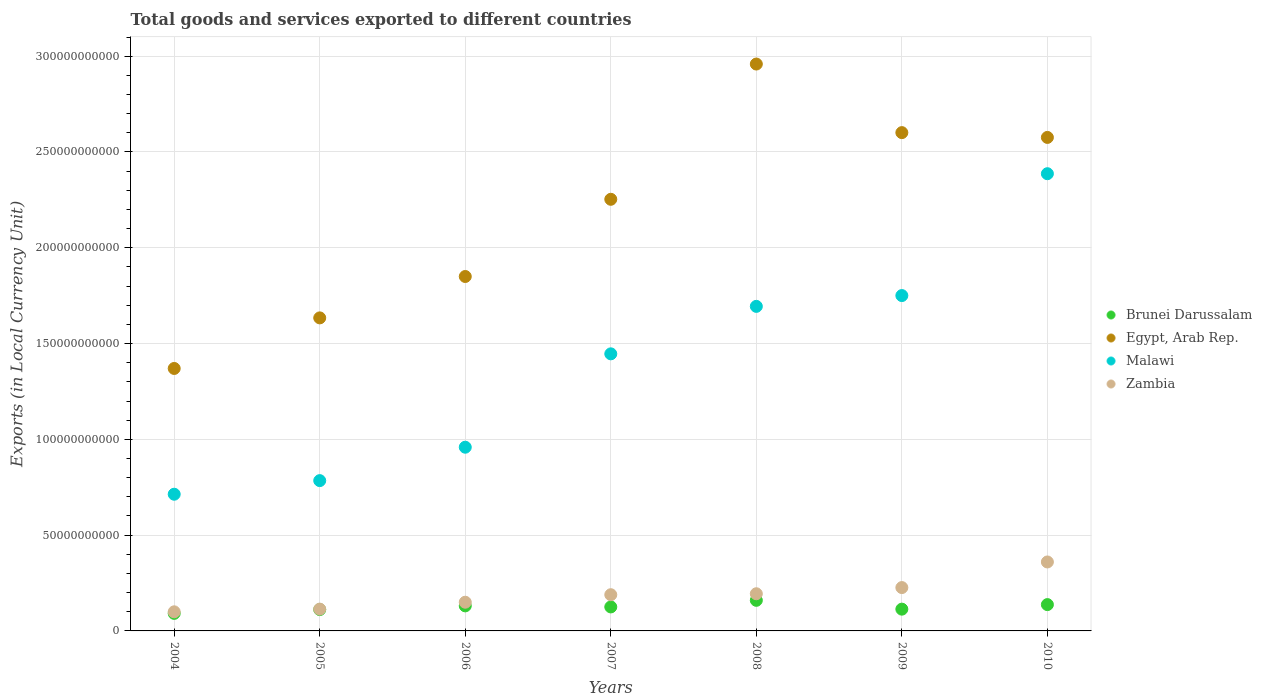Is the number of dotlines equal to the number of legend labels?
Your answer should be compact. Yes. What is the Amount of goods and services exports in Brunei Darussalam in 2007?
Make the answer very short. 1.25e+1. Across all years, what is the maximum Amount of goods and services exports in Brunei Darussalam?
Your answer should be very brief. 1.60e+1. Across all years, what is the minimum Amount of goods and services exports in Egypt, Arab Rep.?
Make the answer very short. 1.37e+11. In which year was the Amount of goods and services exports in Brunei Darussalam minimum?
Ensure brevity in your answer.  2004. What is the total Amount of goods and services exports in Brunei Darussalam in the graph?
Offer a very short reply. 8.70e+1. What is the difference between the Amount of goods and services exports in Egypt, Arab Rep. in 2005 and that in 2006?
Offer a very short reply. -2.16e+1. What is the difference between the Amount of goods and services exports in Zambia in 2006 and the Amount of goods and services exports in Brunei Darussalam in 2010?
Keep it short and to the point. 1.24e+09. What is the average Amount of goods and services exports in Malawi per year?
Your answer should be compact. 1.39e+11. In the year 2005, what is the difference between the Amount of goods and services exports in Zambia and Amount of goods and services exports in Brunei Darussalam?
Give a very brief answer. 2.52e+08. In how many years, is the Amount of goods and services exports in Egypt, Arab Rep. greater than 190000000000 LCU?
Your answer should be very brief. 4. What is the ratio of the Amount of goods and services exports in Zambia in 2006 to that in 2008?
Provide a succinct answer. 0.77. What is the difference between the highest and the second highest Amount of goods and services exports in Zambia?
Offer a terse response. 1.34e+1. What is the difference between the highest and the lowest Amount of goods and services exports in Malawi?
Your answer should be very brief. 1.67e+11. Is the Amount of goods and services exports in Malawi strictly greater than the Amount of goods and services exports in Brunei Darussalam over the years?
Offer a terse response. Yes. Is the Amount of goods and services exports in Zambia strictly less than the Amount of goods and services exports in Egypt, Arab Rep. over the years?
Give a very brief answer. Yes. How many dotlines are there?
Give a very brief answer. 4. How many years are there in the graph?
Offer a very short reply. 7. What is the difference between two consecutive major ticks on the Y-axis?
Give a very brief answer. 5.00e+1. Does the graph contain any zero values?
Make the answer very short. No. Does the graph contain grids?
Make the answer very short. Yes. How many legend labels are there?
Keep it short and to the point. 4. What is the title of the graph?
Provide a succinct answer. Total goods and services exported to different countries. What is the label or title of the X-axis?
Provide a succinct answer. Years. What is the label or title of the Y-axis?
Keep it short and to the point. Exports (in Local Currency Unit). What is the Exports (in Local Currency Unit) of Brunei Darussalam in 2004?
Give a very brief answer. 9.15e+09. What is the Exports (in Local Currency Unit) in Egypt, Arab Rep. in 2004?
Make the answer very short. 1.37e+11. What is the Exports (in Local Currency Unit) in Malawi in 2004?
Your answer should be very brief. 7.14e+1. What is the Exports (in Local Currency Unit) in Zambia in 2004?
Offer a terse response. 9.97e+09. What is the Exports (in Local Currency Unit) of Brunei Darussalam in 2005?
Offer a terse response. 1.11e+1. What is the Exports (in Local Currency Unit) of Egypt, Arab Rep. in 2005?
Provide a short and direct response. 1.63e+11. What is the Exports (in Local Currency Unit) in Malawi in 2005?
Ensure brevity in your answer.  7.85e+1. What is the Exports (in Local Currency Unit) of Zambia in 2005?
Keep it short and to the point. 1.14e+1. What is the Exports (in Local Currency Unit) of Brunei Darussalam in 2006?
Keep it short and to the point. 1.31e+1. What is the Exports (in Local Currency Unit) of Egypt, Arab Rep. in 2006?
Offer a terse response. 1.85e+11. What is the Exports (in Local Currency Unit) in Malawi in 2006?
Give a very brief answer. 9.59e+1. What is the Exports (in Local Currency Unit) in Zambia in 2006?
Offer a terse response. 1.50e+1. What is the Exports (in Local Currency Unit) in Brunei Darussalam in 2007?
Give a very brief answer. 1.25e+1. What is the Exports (in Local Currency Unit) of Egypt, Arab Rep. in 2007?
Give a very brief answer. 2.25e+11. What is the Exports (in Local Currency Unit) in Malawi in 2007?
Provide a short and direct response. 1.45e+11. What is the Exports (in Local Currency Unit) in Zambia in 2007?
Provide a short and direct response. 1.89e+1. What is the Exports (in Local Currency Unit) of Brunei Darussalam in 2008?
Make the answer very short. 1.60e+1. What is the Exports (in Local Currency Unit) in Egypt, Arab Rep. in 2008?
Make the answer very short. 2.96e+11. What is the Exports (in Local Currency Unit) of Malawi in 2008?
Ensure brevity in your answer.  1.69e+11. What is the Exports (in Local Currency Unit) in Zambia in 2008?
Make the answer very short. 1.94e+1. What is the Exports (in Local Currency Unit) in Brunei Darussalam in 2009?
Give a very brief answer. 1.14e+1. What is the Exports (in Local Currency Unit) of Egypt, Arab Rep. in 2009?
Make the answer very short. 2.60e+11. What is the Exports (in Local Currency Unit) of Malawi in 2009?
Your answer should be compact. 1.75e+11. What is the Exports (in Local Currency Unit) of Zambia in 2009?
Your response must be concise. 2.26e+1. What is the Exports (in Local Currency Unit) in Brunei Darussalam in 2010?
Keep it short and to the point. 1.37e+1. What is the Exports (in Local Currency Unit) of Egypt, Arab Rep. in 2010?
Offer a terse response. 2.58e+11. What is the Exports (in Local Currency Unit) of Malawi in 2010?
Your response must be concise. 2.39e+11. What is the Exports (in Local Currency Unit) of Zambia in 2010?
Keep it short and to the point. 3.60e+1. Across all years, what is the maximum Exports (in Local Currency Unit) in Brunei Darussalam?
Provide a short and direct response. 1.60e+1. Across all years, what is the maximum Exports (in Local Currency Unit) in Egypt, Arab Rep.?
Your answer should be very brief. 2.96e+11. Across all years, what is the maximum Exports (in Local Currency Unit) in Malawi?
Your answer should be compact. 2.39e+11. Across all years, what is the maximum Exports (in Local Currency Unit) of Zambia?
Provide a short and direct response. 3.60e+1. Across all years, what is the minimum Exports (in Local Currency Unit) of Brunei Darussalam?
Your response must be concise. 9.15e+09. Across all years, what is the minimum Exports (in Local Currency Unit) of Egypt, Arab Rep.?
Provide a short and direct response. 1.37e+11. Across all years, what is the minimum Exports (in Local Currency Unit) of Malawi?
Your answer should be very brief. 7.14e+1. Across all years, what is the minimum Exports (in Local Currency Unit) in Zambia?
Provide a short and direct response. 9.97e+09. What is the total Exports (in Local Currency Unit) of Brunei Darussalam in the graph?
Provide a succinct answer. 8.70e+1. What is the total Exports (in Local Currency Unit) in Egypt, Arab Rep. in the graph?
Keep it short and to the point. 1.52e+12. What is the total Exports (in Local Currency Unit) of Malawi in the graph?
Your response must be concise. 9.73e+11. What is the total Exports (in Local Currency Unit) in Zambia in the graph?
Provide a succinct answer. 1.33e+11. What is the difference between the Exports (in Local Currency Unit) in Brunei Darussalam in 2004 and that in 2005?
Offer a very short reply. -1.98e+09. What is the difference between the Exports (in Local Currency Unit) of Egypt, Arab Rep. in 2004 and that in 2005?
Provide a succinct answer. -2.64e+1. What is the difference between the Exports (in Local Currency Unit) in Malawi in 2004 and that in 2005?
Make the answer very short. -7.10e+09. What is the difference between the Exports (in Local Currency Unit) of Zambia in 2004 and that in 2005?
Your response must be concise. -1.41e+09. What is the difference between the Exports (in Local Currency Unit) of Brunei Darussalam in 2004 and that in 2006?
Make the answer very short. -3.92e+09. What is the difference between the Exports (in Local Currency Unit) of Egypt, Arab Rep. in 2004 and that in 2006?
Give a very brief answer. -4.80e+1. What is the difference between the Exports (in Local Currency Unit) in Malawi in 2004 and that in 2006?
Make the answer very short. -2.45e+1. What is the difference between the Exports (in Local Currency Unit) in Zambia in 2004 and that in 2006?
Provide a short and direct response. -5.01e+09. What is the difference between the Exports (in Local Currency Unit) in Brunei Darussalam in 2004 and that in 2007?
Your answer should be very brief. -3.37e+09. What is the difference between the Exports (in Local Currency Unit) in Egypt, Arab Rep. in 2004 and that in 2007?
Make the answer very short. -8.83e+1. What is the difference between the Exports (in Local Currency Unit) of Malawi in 2004 and that in 2007?
Provide a succinct answer. -7.33e+1. What is the difference between the Exports (in Local Currency Unit) in Zambia in 2004 and that in 2007?
Offer a very short reply. -8.93e+09. What is the difference between the Exports (in Local Currency Unit) in Brunei Darussalam in 2004 and that in 2008?
Your response must be concise. -6.82e+09. What is the difference between the Exports (in Local Currency Unit) in Egypt, Arab Rep. in 2004 and that in 2008?
Offer a very short reply. -1.59e+11. What is the difference between the Exports (in Local Currency Unit) of Malawi in 2004 and that in 2008?
Your answer should be very brief. -9.81e+1. What is the difference between the Exports (in Local Currency Unit) in Zambia in 2004 and that in 2008?
Offer a terse response. -9.43e+09. What is the difference between the Exports (in Local Currency Unit) in Brunei Darussalam in 2004 and that in 2009?
Provide a succinct answer. -2.21e+09. What is the difference between the Exports (in Local Currency Unit) in Egypt, Arab Rep. in 2004 and that in 2009?
Ensure brevity in your answer.  -1.23e+11. What is the difference between the Exports (in Local Currency Unit) of Malawi in 2004 and that in 2009?
Keep it short and to the point. -1.04e+11. What is the difference between the Exports (in Local Currency Unit) in Zambia in 2004 and that in 2009?
Offer a very short reply. -1.27e+1. What is the difference between the Exports (in Local Currency Unit) in Brunei Darussalam in 2004 and that in 2010?
Provide a succinct answer. -4.58e+09. What is the difference between the Exports (in Local Currency Unit) in Egypt, Arab Rep. in 2004 and that in 2010?
Your answer should be compact. -1.21e+11. What is the difference between the Exports (in Local Currency Unit) of Malawi in 2004 and that in 2010?
Keep it short and to the point. -1.67e+11. What is the difference between the Exports (in Local Currency Unit) in Zambia in 2004 and that in 2010?
Provide a succinct answer. -2.60e+1. What is the difference between the Exports (in Local Currency Unit) in Brunei Darussalam in 2005 and that in 2006?
Give a very brief answer. -1.94e+09. What is the difference between the Exports (in Local Currency Unit) in Egypt, Arab Rep. in 2005 and that in 2006?
Your response must be concise. -2.16e+1. What is the difference between the Exports (in Local Currency Unit) of Malawi in 2005 and that in 2006?
Your answer should be compact. -1.74e+1. What is the difference between the Exports (in Local Currency Unit) of Zambia in 2005 and that in 2006?
Give a very brief answer. -3.60e+09. What is the difference between the Exports (in Local Currency Unit) in Brunei Darussalam in 2005 and that in 2007?
Your response must be concise. -1.39e+09. What is the difference between the Exports (in Local Currency Unit) of Egypt, Arab Rep. in 2005 and that in 2007?
Provide a succinct answer. -6.19e+1. What is the difference between the Exports (in Local Currency Unit) in Malawi in 2005 and that in 2007?
Offer a very short reply. -6.62e+1. What is the difference between the Exports (in Local Currency Unit) in Zambia in 2005 and that in 2007?
Give a very brief answer. -7.52e+09. What is the difference between the Exports (in Local Currency Unit) of Brunei Darussalam in 2005 and that in 2008?
Give a very brief answer. -4.84e+09. What is the difference between the Exports (in Local Currency Unit) in Egypt, Arab Rep. in 2005 and that in 2008?
Provide a short and direct response. -1.32e+11. What is the difference between the Exports (in Local Currency Unit) in Malawi in 2005 and that in 2008?
Give a very brief answer. -9.10e+1. What is the difference between the Exports (in Local Currency Unit) in Zambia in 2005 and that in 2008?
Your answer should be very brief. -8.02e+09. What is the difference between the Exports (in Local Currency Unit) in Brunei Darussalam in 2005 and that in 2009?
Provide a short and direct response. -2.31e+08. What is the difference between the Exports (in Local Currency Unit) of Egypt, Arab Rep. in 2005 and that in 2009?
Ensure brevity in your answer.  -9.67e+1. What is the difference between the Exports (in Local Currency Unit) in Malawi in 2005 and that in 2009?
Provide a short and direct response. -9.66e+1. What is the difference between the Exports (in Local Currency Unit) of Zambia in 2005 and that in 2009?
Provide a short and direct response. -1.12e+1. What is the difference between the Exports (in Local Currency Unit) of Brunei Darussalam in 2005 and that in 2010?
Your answer should be very brief. -2.60e+09. What is the difference between the Exports (in Local Currency Unit) in Egypt, Arab Rep. in 2005 and that in 2010?
Give a very brief answer. -9.42e+1. What is the difference between the Exports (in Local Currency Unit) in Malawi in 2005 and that in 2010?
Your answer should be compact. -1.60e+11. What is the difference between the Exports (in Local Currency Unit) in Zambia in 2005 and that in 2010?
Give a very brief answer. -2.46e+1. What is the difference between the Exports (in Local Currency Unit) of Brunei Darussalam in 2006 and that in 2007?
Offer a terse response. 5.48e+08. What is the difference between the Exports (in Local Currency Unit) of Egypt, Arab Rep. in 2006 and that in 2007?
Ensure brevity in your answer.  -4.03e+1. What is the difference between the Exports (in Local Currency Unit) in Malawi in 2006 and that in 2007?
Keep it short and to the point. -4.87e+1. What is the difference between the Exports (in Local Currency Unit) of Zambia in 2006 and that in 2007?
Provide a short and direct response. -3.92e+09. What is the difference between the Exports (in Local Currency Unit) in Brunei Darussalam in 2006 and that in 2008?
Offer a very short reply. -2.90e+09. What is the difference between the Exports (in Local Currency Unit) in Egypt, Arab Rep. in 2006 and that in 2008?
Offer a terse response. -1.11e+11. What is the difference between the Exports (in Local Currency Unit) in Malawi in 2006 and that in 2008?
Offer a terse response. -7.35e+1. What is the difference between the Exports (in Local Currency Unit) in Zambia in 2006 and that in 2008?
Your response must be concise. -4.42e+09. What is the difference between the Exports (in Local Currency Unit) in Brunei Darussalam in 2006 and that in 2009?
Make the answer very short. 1.71e+09. What is the difference between the Exports (in Local Currency Unit) in Egypt, Arab Rep. in 2006 and that in 2009?
Keep it short and to the point. -7.51e+1. What is the difference between the Exports (in Local Currency Unit) of Malawi in 2006 and that in 2009?
Your response must be concise. -7.92e+1. What is the difference between the Exports (in Local Currency Unit) of Zambia in 2006 and that in 2009?
Give a very brief answer. -7.64e+09. What is the difference between the Exports (in Local Currency Unit) in Brunei Darussalam in 2006 and that in 2010?
Your response must be concise. -6.64e+08. What is the difference between the Exports (in Local Currency Unit) in Egypt, Arab Rep. in 2006 and that in 2010?
Offer a very short reply. -7.26e+1. What is the difference between the Exports (in Local Currency Unit) in Malawi in 2006 and that in 2010?
Give a very brief answer. -1.43e+11. What is the difference between the Exports (in Local Currency Unit) in Zambia in 2006 and that in 2010?
Keep it short and to the point. -2.10e+1. What is the difference between the Exports (in Local Currency Unit) in Brunei Darussalam in 2007 and that in 2008?
Provide a succinct answer. -3.45e+09. What is the difference between the Exports (in Local Currency Unit) of Egypt, Arab Rep. in 2007 and that in 2008?
Provide a succinct answer. -7.06e+1. What is the difference between the Exports (in Local Currency Unit) of Malawi in 2007 and that in 2008?
Give a very brief answer. -2.48e+1. What is the difference between the Exports (in Local Currency Unit) in Zambia in 2007 and that in 2008?
Provide a short and direct response. -5.02e+08. What is the difference between the Exports (in Local Currency Unit) in Brunei Darussalam in 2007 and that in 2009?
Your answer should be very brief. 1.16e+09. What is the difference between the Exports (in Local Currency Unit) in Egypt, Arab Rep. in 2007 and that in 2009?
Ensure brevity in your answer.  -3.48e+1. What is the difference between the Exports (in Local Currency Unit) in Malawi in 2007 and that in 2009?
Give a very brief answer. -3.04e+1. What is the difference between the Exports (in Local Currency Unit) in Zambia in 2007 and that in 2009?
Your answer should be very brief. -3.73e+09. What is the difference between the Exports (in Local Currency Unit) in Brunei Darussalam in 2007 and that in 2010?
Keep it short and to the point. -1.21e+09. What is the difference between the Exports (in Local Currency Unit) in Egypt, Arab Rep. in 2007 and that in 2010?
Your response must be concise. -3.23e+1. What is the difference between the Exports (in Local Currency Unit) in Malawi in 2007 and that in 2010?
Your answer should be compact. -9.40e+1. What is the difference between the Exports (in Local Currency Unit) in Zambia in 2007 and that in 2010?
Make the answer very short. -1.71e+1. What is the difference between the Exports (in Local Currency Unit) in Brunei Darussalam in 2008 and that in 2009?
Your answer should be very brief. 4.61e+09. What is the difference between the Exports (in Local Currency Unit) of Egypt, Arab Rep. in 2008 and that in 2009?
Your answer should be very brief. 3.58e+1. What is the difference between the Exports (in Local Currency Unit) in Malawi in 2008 and that in 2009?
Your response must be concise. -5.64e+09. What is the difference between the Exports (in Local Currency Unit) of Zambia in 2008 and that in 2009?
Offer a very short reply. -3.22e+09. What is the difference between the Exports (in Local Currency Unit) in Brunei Darussalam in 2008 and that in 2010?
Provide a short and direct response. 2.23e+09. What is the difference between the Exports (in Local Currency Unit) in Egypt, Arab Rep. in 2008 and that in 2010?
Your response must be concise. 3.83e+1. What is the difference between the Exports (in Local Currency Unit) of Malawi in 2008 and that in 2010?
Your response must be concise. -6.92e+1. What is the difference between the Exports (in Local Currency Unit) of Zambia in 2008 and that in 2010?
Ensure brevity in your answer.  -1.66e+1. What is the difference between the Exports (in Local Currency Unit) of Brunei Darussalam in 2009 and that in 2010?
Offer a very short reply. -2.37e+09. What is the difference between the Exports (in Local Currency Unit) in Egypt, Arab Rep. in 2009 and that in 2010?
Provide a succinct answer. 2.50e+09. What is the difference between the Exports (in Local Currency Unit) in Malawi in 2009 and that in 2010?
Keep it short and to the point. -6.36e+1. What is the difference between the Exports (in Local Currency Unit) of Zambia in 2009 and that in 2010?
Offer a very short reply. -1.34e+1. What is the difference between the Exports (in Local Currency Unit) in Brunei Darussalam in 2004 and the Exports (in Local Currency Unit) in Egypt, Arab Rep. in 2005?
Make the answer very short. -1.54e+11. What is the difference between the Exports (in Local Currency Unit) of Brunei Darussalam in 2004 and the Exports (in Local Currency Unit) of Malawi in 2005?
Make the answer very short. -6.93e+1. What is the difference between the Exports (in Local Currency Unit) of Brunei Darussalam in 2004 and the Exports (in Local Currency Unit) of Zambia in 2005?
Your response must be concise. -2.23e+09. What is the difference between the Exports (in Local Currency Unit) of Egypt, Arab Rep. in 2004 and the Exports (in Local Currency Unit) of Malawi in 2005?
Your answer should be very brief. 5.85e+1. What is the difference between the Exports (in Local Currency Unit) in Egypt, Arab Rep. in 2004 and the Exports (in Local Currency Unit) in Zambia in 2005?
Your answer should be very brief. 1.26e+11. What is the difference between the Exports (in Local Currency Unit) in Malawi in 2004 and the Exports (in Local Currency Unit) in Zambia in 2005?
Offer a terse response. 6.00e+1. What is the difference between the Exports (in Local Currency Unit) of Brunei Darussalam in 2004 and the Exports (in Local Currency Unit) of Egypt, Arab Rep. in 2006?
Your answer should be compact. -1.76e+11. What is the difference between the Exports (in Local Currency Unit) in Brunei Darussalam in 2004 and the Exports (in Local Currency Unit) in Malawi in 2006?
Provide a short and direct response. -8.67e+1. What is the difference between the Exports (in Local Currency Unit) of Brunei Darussalam in 2004 and the Exports (in Local Currency Unit) of Zambia in 2006?
Make the answer very short. -5.83e+09. What is the difference between the Exports (in Local Currency Unit) in Egypt, Arab Rep. in 2004 and the Exports (in Local Currency Unit) in Malawi in 2006?
Offer a terse response. 4.11e+1. What is the difference between the Exports (in Local Currency Unit) of Egypt, Arab Rep. in 2004 and the Exports (in Local Currency Unit) of Zambia in 2006?
Your response must be concise. 1.22e+11. What is the difference between the Exports (in Local Currency Unit) in Malawi in 2004 and the Exports (in Local Currency Unit) in Zambia in 2006?
Provide a succinct answer. 5.64e+1. What is the difference between the Exports (in Local Currency Unit) of Brunei Darussalam in 2004 and the Exports (in Local Currency Unit) of Egypt, Arab Rep. in 2007?
Give a very brief answer. -2.16e+11. What is the difference between the Exports (in Local Currency Unit) of Brunei Darussalam in 2004 and the Exports (in Local Currency Unit) of Malawi in 2007?
Offer a very short reply. -1.35e+11. What is the difference between the Exports (in Local Currency Unit) of Brunei Darussalam in 2004 and the Exports (in Local Currency Unit) of Zambia in 2007?
Give a very brief answer. -9.75e+09. What is the difference between the Exports (in Local Currency Unit) of Egypt, Arab Rep. in 2004 and the Exports (in Local Currency Unit) of Malawi in 2007?
Make the answer very short. -7.63e+09. What is the difference between the Exports (in Local Currency Unit) in Egypt, Arab Rep. in 2004 and the Exports (in Local Currency Unit) in Zambia in 2007?
Keep it short and to the point. 1.18e+11. What is the difference between the Exports (in Local Currency Unit) in Malawi in 2004 and the Exports (in Local Currency Unit) in Zambia in 2007?
Your answer should be very brief. 5.25e+1. What is the difference between the Exports (in Local Currency Unit) in Brunei Darussalam in 2004 and the Exports (in Local Currency Unit) in Egypt, Arab Rep. in 2008?
Your response must be concise. -2.87e+11. What is the difference between the Exports (in Local Currency Unit) of Brunei Darussalam in 2004 and the Exports (in Local Currency Unit) of Malawi in 2008?
Keep it short and to the point. -1.60e+11. What is the difference between the Exports (in Local Currency Unit) of Brunei Darussalam in 2004 and the Exports (in Local Currency Unit) of Zambia in 2008?
Your response must be concise. -1.02e+1. What is the difference between the Exports (in Local Currency Unit) of Egypt, Arab Rep. in 2004 and the Exports (in Local Currency Unit) of Malawi in 2008?
Offer a terse response. -3.24e+1. What is the difference between the Exports (in Local Currency Unit) in Egypt, Arab Rep. in 2004 and the Exports (in Local Currency Unit) in Zambia in 2008?
Ensure brevity in your answer.  1.18e+11. What is the difference between the Exports (in Local Currency Unit) of Malawi in 2004 and the Exports (in Local Currency Unit) of Zambia in 2008?
Give a very brief answer. 5.20e+1. What is the difference between the Exports (in Local Currency Unit) of Brunei Darussalam in 2004 and the Exports (in Local Currency Unit) of Egypt, Arab Rep. in 2009?
Provide a succinct answer. -2.51e+11. What is the difference between the Exports (in Local Currency Unit) in Brunei Darussalam in 2004 and the Exports (in Local Currency Unit) in Malawi in 2009?
Your answer should be compact. -1.66e+11. What is the difference between the Exports (in Local Currency Unit) in Brunei Darussalam in 2004 and the Exports (in Local Currency Unit) in Zambia in 2009?
Provide a short and direct response. -1.35e+1. What is the difference between the Exports (in Local Currency Unit) of Egypt, Arab Rep. in 2004 and the Exports (in Local Currency Unit) of Malawi in 2009?
Your response must be concise. -3.80e+1. What is the difference between the Exports (in Local Currency Unit) of Egypt, Arab Rep. in 2004 and the Exports (in Local Currency Unit) of Zambia in 2009?
Give a very brief answer. 1.14e+11. What is the difference between the Exports (in Local Currency Unit) in Malawi in 2004 and the Exports (in Local Currency Unit) in Zambia in 2009?
Your answer should be very brief. 4.87e+1. What is the difference between the Exports (in Local Currency Unit) in Brunei Darussalam in 2004 and the Exports (in Local Currency Unit) in Egypt, Arab Rep. in 2010?
Keep it short and to the point. -2.48e+11. What is the difference between the Exports (in Local Currency Unit) in Brunei Darussalam in 2004 and the Exports (in Local Currency Unit) in Malawi in 2010?
Offer a very short reply. -2.30e+11. What is the difference between the Exports (in Local Currency Unit) of Brunei Darussalam in 2004 and the Exports (in Local Currency Unit) of Zambia in 2010?
Provide a short and direct response. -2.68e+1. What is the difference between the Exports (in Local Currency Unit) in Egypt, Arab Rep. in 2004 and the Exports (in Local Currency Unit) in Malawi in 2010?
Your answer should be very brief. -1.02e+11. What is the difference between the Exports (in Local Currency Unit) of Egypt, Arab Rep. in 2004 and the Exports (in Local Currency Unit) of Zambia in 2010?
Ensure brevity in your answer.  1.01e+11. What is the difference between the Exports (in Local Currency Unit) of Malawi in 2004 and the Exports (in Local Currency Unit) of Zambia in 2010?
Provide a succinct answer. 3.54e+1. What is the difference between the Exports (in Local Currency Unit) in Brunei Darussalam in 2005 and the Exports (in Local Currency Unit) in Egypt, Arab Rep. in 2006?
Offer a terse response. -1.74e+11. What is the difference between the Exports (in Local Currency Unit) in Brunei Darussalam in 2005 and the Exports (in Local Currency Unit) in Malawi in 2006?
Provide a succinct answer. -8.48e+1. What is the difference between the Exports (in Local Currency Unit) in Brunei Darussalam in 2005 and the Exports (in Local Currency Unit) in Zambia in 2006?
Ensure brevity in your answer.  -3.85e+09. What is the difference between the Exports (in Local Currency Unit) in Egypt, Arab Rep. in 2005 and the Exports (in Local Currency Unit) in Malawi in 2006?
Make the answer very short. 6.75e+1. What is the difference between the Exports (in Local Currency Unit) in Egypt, Arab Rep. in 2005 and the Exports (in Local Currency Unit) in Zambia in 2006?
Provide a short and direct response. 1.48e+11. What is the difference between the Exports (in Local Currency Unit) in Malawi in 2005 and the Exports (in Local Currency Unit) in Zambia in 2006?
Your response must be concise. 6.35e+1. What is the difference between the Exports (in Local Currency Unit) of Brunei Darussalam in 2005 and the Exports (in Local Currency Unit) of Egypt, Arab Rep. in 2007?
Your answer should be very brief. -2.14e+11. What is the difference between the Exports (in Local Currency Unit) of Brunei Darussalam in 2005 and the Exports (in Local Currency Unit) of Malawi in 2007?
Make the answer very short. -1.33e+11. What is the difference between the Exports (in Local Currency Unit) of Brunei Darussalam in 2005 and the Exports (in Local Currency Unit) of Zambia in 2007?
Give a very brief answer. -7.77e+09. What is the difference between the Exports (in Local Currency Unit) of Egypt, Arab Rep. in 2005 and the Exports (in Local Currency Unit) of Malawi in 2007?
Offer a very short reply. 1.88e+1. What is the difference between the Exports (in Local Currency Unit) of Egypt, Arab Rep. in 2005 and the Exports (in Local Currency Unit) of Zambia in 2007?
Provide a succinct answer. 1.45e+11. What is the difference between the Exports (in Local Currency Unit) in Malawi in 2005 and the Exports (in Local Currency Unit) in Zambia in 2007?
Offer a terse response. 5.96e+1. What is the difference between the Exports (in Local Currency Unit) in Brunei Darussalam in 2005 and the Exports (in Local Currency Unit) in Egypt, Arab Rep. in 2008?
Your answer should be compact. -2.85e+11. What is the difference between the Exports (in Local Currency Unit) in Brunei Darussalam in 2005 and the Exports (in Local Currency Unit) in Malawi in 2008?
Give a very brief answer. -1.58e+11. What is the difference between the Exports (in Local Currency Unit) of Brunei Darussalam in 2005 and the Exports (in Local Currency Unit) of Zambia in 2008?
Give a very brief answer. -8.27e+09. What is the difference between the Exports (in Local Currency Unit) in Egypt, Arab Rep. in 2005 and the Exports (in Local Currency Unit) in Malawi in 2008?
Provide a succinct answer. -6.01e+09. What is the difference between the Exports (in Local Currency Unit) of Egypt, Arab Rep. in 2005 and the Exports (in Local Currency Unit) of Zambia in 2008?
Give a very brief answer. 1.44e+11. What is the difference between the Exports (in Local Currency Unit) in Malawi in 2005 and the Exports (in Local Currency Unit) in Zambia in 2008?
Offer a very short reply. 5.91e+1. What is the difference between the Exports (in Local Currency Unit) in Brunei Darussalam in 2005 and the Exports (in Local Currency Unit) in Egypt, Arab Rep. in 2009?
Your response must be concise. -2.49e+11. What is the difference between the Exports (in Local Currency Unit) of Brunei Darussalam in 2005 and the Exports (in Local Currency Unit) of Malawi in 2009?
Give a very brief answer. -1.64e+11. What is the difference between the Exports (in Local Currency Unit) in Brunei Darussalam in 2005 and the Exports (in Local Currency Unit) in Zambia in 2009?
Ensure brevity in your answer.  -1.15e+1. What is the difference between the Exports (in Local Currency Unit) in Egypt, Arab Rep. in 2005 and the Exports (in Local Currency Unit) in Malawi in 2009?
Make the answer very short. -1.16e+1. What is the difference between the Exports (in Local Currency Unit) in Egypt, Arab Rep. in 2005 and the Exports (in Local Currency Unit) in Zambia in 2009?
Offer a very short reply. 1.41e+11. What is the difference between the Exports (in Local Currency Unit) of Malawi in 2005 and the Exports (in Local Currency Unit) of Zambia in 2009?
Keep it short and to the point. 5.58e+1. What is the difference between the Exports (in Local Currency Unit) in Brunei Darussalam in 2005 and the Exports (in Local Currency Unit) in Egypt, Arab Rep. in 2010?
Ensure brevity in your answer.  -2.46e+11. What is the difference between the Exports (in Local Currency Unit) of Brunei Darussalam in 2005 and the Exports (in Local Currency Unit) of Malawi in 2010?
Offer a terse response. -2.28e+11. What is the difference between the Exports (in Local Currency Unit) in Brunei Darussalam in 2005 and the Exports (in Local Currency Unit) in Zambia in 2010?
Provide a succinct answer. -2.49e+1. What is the difference between the Exports (in Local Currency Unit) of Egypt, Arab Rep. in 2005 and the Exports (in Local Currency Unit) of Malawi in 2010?
Your response must be concise. -7.53e+1. What is the difference between the Exports (in Local Currency Unit) in Egypt, Arab Rep. in 2005 and the Exports (in Local Currency Unit) in Zambia in 2010?
Make the answer very short. 1.27e+11. What is the difference between the Exports (in Local Currency Unit) of Malawi in 2005 and the Exports (in Local Currency Unit) of Zambia in 2010?
Offer a very short reply. 4.25e+1. What is the difference between the Exports (in Local Currency Unit) in Brunei Darussalam in 2006 and the Exports (in Local Currency Unit) in Egypt, Arab Rep. in 2007?
Your answer should be compact. -2.12e+11. What is the difference between the Exports (in Local Currency Unit) of Brunei Darussalam in 2006 and the Exports (in Local Currency Unit) of Malawi in 2007?
Your answer should be very brief. -1.32e+11. What is the difference between the Exports (in Local Currency Unit) in Brunei Darussalam in 2006 and the Exports (in Local Currency Unit) in Zambia in 2007?
Offer a terse response. -5.83e+09. What is the difference between the Exports (in Local Currency Unit) in Egypt, Arab Rep. in 2006 and the Exports (in Local Currency Unit) in Malawi in 2007?
Offer a very short reply. 4.04e+1. What is the difference between the Exports (in Local Currency Unit) of Egypt, Arab Rep. in 2006 and the Exports (in Local Currency Unit) of Zambia in 2007?
Offer a terse response. 1.66e+11. What is the difference between the Exports (in Local Currency Unit) of Malawi in 2006 and the Exports (in Local Currency Unit) of Zambia in 2007?
Your response must be concise. 7.70e+1. What is the difference between the Exports (in Local Currency Unit) of Brunei Darussalam in 2006 and the Exports (in Local Currency Unit) of Egypt, Arab Rep. in 2008?
Your answer should be compact. -2.83e+11. What is the difference between the Exports (in Local Currency Unit) in Brunei Darussalam in 2006 and the Exports (in Local Currency Unit) in Malawi in 2008?
Your answer should be compact. -1.56e+11. What is the difference between the Exports (in Local Currency Unit) of Brunei Darussalam in 2006 and the Exports (in Local Currency Unit) of Zambia in 2008?
Your response must be concise. -6.33e+09. What is the difference between the Exports (in Local Currency Unit) in Egypt, Arab Rep. in 2006 and the Exports (in Local Currency Unit) in Malawi in 2008?
Your answer should be compact. 1.56e+1. What is the difference between the Exports (in Local Currency Unit) in Egypt, Arab Rep. in 2006 and the Exports (in Local Currency Unit) in Zambia in 2008?
Provide a succinct answer. 1.66e+11. What is the difference between the Exports (in Local Currency Unit) in Malawi in 2006 and the Exports (in Local Currency Unit) in Zambia in 2008?
Provide a short and direct response. 7.65e+1. What is the difference between the Exports (in Local Currency Unit) in Brunei Darussalam in 2006 and the Exports (in Local Currency Unit) in Egypt, Arab Rep. in 2009?
Make the answer very short. -2.47e+11. What is the difference between the Exports (in Local Currency Unit) of Brunei Darussalam in 2006 and the Exports (in Local Currency Unit) of Malawi in 2009?
Provide a short and direct response. -1.62e+11. What is the difference between the Exports (in Local Currency Unit) in Brunei Darussalam in 2006 and the Exports (in Local Currency Unit) in Zambia in 2009?
Your answer should be compact. -9.55e+09. What is the difference between the Exports (in Local Currency Unit) of Egypt, Arab Rep. in 2006 and the Exports (in Local Currency Unit) of Malawi in 2009?
Provide a short and direct response. 9.95e+09. What is the difference between the Exports (in Local Currency Unit) of Egypt, Arab Rep. in 2006 and the Exports (in Local Currency Unit) of Zambia in 2009?
Your response must be concise. 1.62e+11. What is the difference between the Exports (in Local Currency Unit) of Malawi in 2006 and the Exports (in Local Currency Unit) of Zambia in 2009?
Give a very brief answer. 7.33e+1. What is the difference between the Exports (in Local Currency Unit) of Brunei Darussalam in 2006 and the Exports (in Local Currency Unit) of Egypt, Arab Rep. in 2010?
Provide a succinct answer. -2.45e+11. What is the difference between the Exports (in Local Currency Unit) of Brunei Darussalam in 2006 and the Exports (in Local Currency Unit) of Malawi in 2010?
Your response must be concise. -2.26e+11. What is the difference between the Exports (in Local Currency Unit) in Brunei Darussalam in 2006 and the Exports (in Local Currency Unit) in Zambia in 2010?
Make the answer very short. -2.29e+1. What is the difference between the Exports (in Local Currency Unit) of Egypt, Arab Rep. in 2006 and the Exports (in Local Currency Unit) of Malawi in 2010?
Offer a very short reply. -5.37e+1. What is the difference between the Exports (in Local Currency Unit) of Egypt, Arab Rep. in 2006 and the Exports (in Local Currency Unit) of Zambia in 2010?
Ensure brevity in your answer.  1.49e+11. What is the difference between the Exports (in Local Currency Unit) in Malawi in 2006 and the Exports (in Local Currency Unit) in Zambia in 2010?
Keep it short and to the point. 5.99e+1. What is the difference between the Exports (in Local Currency Unit) in Brunei Darussalam in 2007 and the Exports (in Local Currency Unit) in Egypt, Arab Rep. in 2008?
Make the answer very short. -2.83e+11. What is the difference between the Exports (in Local Currency Unit) in Brunei Darussalam in 2007 and the Exports (in Local Currency Unit) in Malawi in 2008?
Ensure brevity in your answer.  -1.57e+11. What is the difference between the Exports (in Local Currency Unit) in Brunei Darussalam in 2007 and the Exports (in Local Currency Unit) in Zambia in 2008?
Provide a short and direct response. -6.88e+09. What is the difference between the Exports (in Local Currency Unit) of Egypt, Arab Rep. in 2007 and the Exports (in Local Currency Unit) of Malawi in 2008?
Provide a succinct answer. 5.59e+1. What is the difference between the Exports (in Local Currency Unit) of Egypt, Arab Rep. in 2007 and the Exports (in Local Currency Unit) of Zambia in 2008?
Offer a very short reply. 2.06e+11. What is the difference between the Exports (in Local Currency Unit) of Malawi in 2007 and the Exports (in Local Currency Unit) of Zambia in 2008?
Make the answer very short. 1.25e+11. What is the difference between the Exports (in Local Currency Unit) in Brunei Darussalam in 2007 and the Exports (in Local Currency Unit) in Egypt, Arab Rep. in 2009?
Offer a very short reply. -2.48e+11. What is the difference between the Exports (in Local Currency Unit) in Brunei Darussalam in 2007 and the Exports (in Local Currency Unit) in Malawi in 2009?
Provide a short and direct response. -1.63e+11. What is the difference between the Exports (in Local Currency Unit) in Brunei Darussalam in 2007 and the Exports (in Local Currency Unit) in Zambia in 2009?
Provide a succinct answer. -1.01e+1. What is the difference between the Exports (in Local Currency Unit) in Egypt, Arab Rep. in 2007 and the Exports (in Local Currency Unit) in Malawi in 2009?
Provide a succinct answer. 5.03e+1. What is the difference between the Exports (in Local Currency Unit) of Egypt, Arab Rep. in 2007 and the Exports (in Local Currency Unit) of Zambia in 2009?
Offer a terse response. 2.03e+11. What is the difference between the Exports (in Local Currency Unit) of Malawi in 2007 and the Exports (in Local Currency Unit) of Zambia in 2009?
Give a very brief answer. 1.22e+11. What is the difference between the Exports (in Local Currency Unit) of Brunei Darussalam in 2007 and the Exports (in Local Currency Unit) of Egypt, Arab Rep. in 2010?
Provide a short and direct response. -2.45e+11. What is the difference between the Exports (in Local Currency Unit) of Brunei Darussalam in 2007 and the Exports (in Local Currency Unit) of Malawi in 2010?
Give a very brief answer. -2.26e+11. What is the difference between the Exports (in Local Currency Unit) of Brunei Darussalam in 2007 and the Exports (in Local Currency Unit) of Zambia in 2010?
Keep it short and to the point. -2.35e+1. What is the difference between the Exports (in Local Currency Unit) in Egypt, Arab Rep. in 2007 and the Exports (in Local Currency Unit) in Malawi in 2010?
Ensure brevity in your answer.  -1.34e+1. What is the difference between the Exports (in Local Currency Unit) in Egypt, Arab Rep. in 2007 and the Exports (in Local Currency Unit) in Zambia in 2010?
Provide a succinct answer. 1.89e+11. What is the difference between the Exports (in Local Currency Unit) of Malawi in 2007 and the Exports (in Local Currency Unit) of Zambia in 2010?
Give a very brief answer. 1.09e+11. What is the difference between the Exports (in Local Currency Unit) in Brunei Darussalam in 2008 and the Exports (in Local Currency Unit) in Egypt, Arab Rep. in 2009?
Give a very brief answer. -2.44e+11. What is the difference between the Exports (in Local Currency Unit) in Brunei Darussalam in 2008 and the Exports (in Local Currency Unit) in Malawi in 2009?
Give a very brief answer. -1.59e+11. What is the difference between the Exports (in Local Currency Unit) of Brunei Darussalam in 2008 and the Exports (in Local Currency Unit) of Zambia in 2009?
Offer a very short reply. -6.65e+09. What is the difference between the Exports (in Local Currency Unit) of Egypt, Arab Rep. in 2008 and the Exports (in Local Currency Unit) of Malawi in 2009?
Ensure brevity in your answer.  1.21e+11. What is the difference between the Exports (in Local Currency Unit) of Egypt, Arab Rep. in 2008 and the Exports (in Local Currency Unit) of Zambia in 2009?
Your answer should be compact. 2.73e+11. What is the difference between the Exports (in Local Currency Unit) of Malawi in 2008 and the Exports (in Local Currency Unit) of Zambia in 2009?
Your response must be concise. 1.47e+11. What is the difference between the Exports (in Local Currency Unit) of Brunei Darussalam in 2008 and the Exports (in Local Currency Unit) of Egypt, Arab Rep. in 2010?
Your response must be concise. -2.42e+11. What is the difference between the Exports (in Local Currency Unit) in Brunei Darussalam in 2008 and the Exports (in Local Currency Unit) in Malawi in 2010?
Ensure brevity in your answer.  -2.23e+11. What is the difference between the Exports (in Local Currency Unit) of Brunei Darussalam in 2008 and the Exports (in Local Currency Unit) of Zambia in 2010?
Make the answer very short. -2.00e+1. What is the difference between the Exports (in Local Currency Unit) in Egypt, Arab Rep. in 2008 and the Exports (in Local Currency Unit) in Malawi in 2010?
Keep it short and to the point. 5.72e+1. What is the difference between the Exports (in Local Currency Unit) in Egypt, Arab Rep. in 2008 and the Exports (in Local Currency Unit) in Zambia in 2010?
Offer a terse response. 2.60e+11. What is the difference between the Exports (in Local Currency Unit) of Malawi in 2008 and the Exports (in Local Currency Unit) of Zambia in 2010?
Ensure brevity in your answer.  1.33e+11. What is the difference between the Exports (in Local Currency Unit) of Brunei Darussalam in 2009 and the Exports (in Local Currency Unit) of Egypt, Arab Rep. in 2010?
Your response must be concise. -2.46e+11. What is the difference between the Exports (in Local Currency Unit) of Brunei Darussalam in 2009 and the Exports (in Local Currency Unit) of Malawi in 2010?
Offer a terse response. -2.27e+11. What is the difference between the Exports (in Local Currency Unit) in Brunei Darussalam in 2009 and the Exports (in Local Currency Unit) in Zambia in 2010?
Your response must be concise. -2.46e+1. What is the difference between the Exports (in Local Currency Unit) of Egypt, Arab Rep. in 2009 and the Exports (in Local Currency Unit) of Malawi in 2010?
Your response must be concise. 2.14e+1. What is the difference between the Exports (in Local Currency Unit) of Egypt, Arab Rep. in 2009 and the Exports (in Local Currency Unit) of Zambia in 2010?
Keep it short and to the point. 2.24e+11. What is the difference between the Exports (in Local Currency Unit) in Malawi in 2009 and the Exports (in Local Currency Unit) in Zambia in 2010?
Ensure brevity in your answer.  1.39e+11. What is the average Exports (in Local Currency Unit) of Brunei Darussalam per year?
Provide a short and direct response. 1.24e+1. What is the average Exports (in Local Currency Unit) of Egypt, Arab Rep. per year?
Your response must be concise. 2.18e+11. What is the average Exports (in Local Currency Unit) in Malawi per year?
Your answer should be compact. 1.39e+11. What is the average Exports (in Local Currency Unit) in Zambia per year?
Offer a very short reply. 1.90e+1. In the year 2004, what is the difference between the Exports (in Local Currency Unit) in Brunei Darussalam and Exports (in Local Currency Unit) in Egypt, Arab Rep.?
Ensure brevity in your answer.  -1.28e+11. In the year 2004, what is the difference between the Exports (in Local Currency Unit) of Brunei Darussalam and Exports (in Local Currency Unit) of Malawi?
Keep it short and to the point. -6.22e+1. In the year 2004, what is the difference between the Exports (in Local Currency Unit) in Brunei Darussalam and Exports (in Local Currency Unit) in Zambia?
Provide a succinct answer. -8.17e+08. In the year 2004, what is the difference between the Exports (in Local Currency Unit) in Egypt, Arab Rep. and Exports (in Local Currency Unit) in Malawi?
Provide a short and direct response. 6.56e+1. In the year 2004, what is the difference between the Exports (in Local Currency Unit) in Egypt, Arab Rep. and Exports (in Local Currency Unit) in Zambia?
Your answer should be compact. 1.27e+11. In the year 2004, what is the difference between the Exports (in Local Currency Unit) in Malawi and Exports (in Local Currency Unit) in Zambia?
Give a very brief answer. 6.14e+1. In the year 2005, what is the difference between the Exports (in Local Currency Unit) in Brunei Darussalam and Exports (in Local Currency Unit) in Egypt, Arab Rep.?
Give a very brief answer. -1.52e+11. In the year 2005, what is the difference between the Exports (in Local Currency Unit) of Brunei Darussalam and Exports (in Local Currency Unit) of Malawi?
Ensure brevity in your answer.  -6.73e+1. In the year 2005, what is the difference between the Exports (in Local Currency Unit) in Brunei Darussalam and Exports (in Local Currency Unit) in Zambia?
Provide a succinct answer. -2.52e+08. In the year 2005, what is the difference between the Exports (in Local Currency Unit) of Egypt, Arab Rep. and Exports (in Local Currency Unit) of Malawi?
Keep it short and to the point. 8.49e+1. In the year 2005, what is the difference between the Exports (in Local Currency Unit) of Egypt, Arab Rep. and Exports (in Local Currency Unit) of Zambia?
Your response must be concise. 1.52e+11. In the year 2005, what is the difference between the Exports (in Local Currency Unit) in Malawi and Exports (in Local Currency Unit) in Zambia?
Your answer should be compact. 6.71e+1. In the year 2006, what is the difference between the Exports (in Local Currency Unit) of Brunei Darussalam and Exports (in Local Currency Unit) of Egypt, Arab Rep.?
Provide a succinct answer. -1.72e+11. In the year 2006, what is the difference between the Exports (in Local Currency Unit) in Brunei Darussalam and Exports (in Local Currency Unit) in Malawi?
Your response must be concise. -8.28e+1. In the year 2006, what is the difference between the Exports (in Local Currency Unit) in Brunei Darussalam and Exports (in Local Currency Unit) in Zambia?
Keep it short and to the point. -1.91e+09. In the year 2006, what is the difference between the Exports (in Local Currency Unit) in Egypt, Arab Rep. and Exports (in Local Currency Unit) in Malawi?
Your answer should be compact. 8.91e+1. In the year 2006, what is the difference between the Exports (in Local Currency Unit) of Egypt, Arab Rep. and Exports (in Local Currency Unit) of Zambia?
Your answer should be very brief. 1.70e+11. In the year 2006, what is the difference between the Exports (in Local Currency Unit) of Malawi and Exports (in Local Currency Unit) of Zambia?
Keep it short and to the point. 8.09e+1. In the year 2007, what is the difference between the Exports (in Local Currency Unit) of Brunei Darussalam and Exports (in Local Currency Unit) of Egypt, Arab Rep.?
Your response must be concise. -2.13e+11. In the year 2007, what is the difference between the Exports (in Local Currency Unit) in Brunei Darussalam and Exports (in Local Currency Unit) in Malawi?
Keep it short and to the point. -1.32e+11. In the year 2007, what is the difference between the Exports (in Local Currency Unit) in Brunei Darussalam and Exports (in Local Currency Unit) in Zambia?
Offer a terse response. -6.37e+09. In the year 2007, what is the difference between the Exports (in Local Currency Unit) in Egypt, Arab Rep. and Exports (in Local Currency Unit) in Malawi?
Your answer should be compact. 8.07e+1. In the year 2007, what is the difference between the Exports (in Local Currency Unit) of Egypt, Arab Rep. and Exports (in Local Currency Unit) of Zambia?
Give a very brief answer. 2.06e+11. In the year 2007, what is the difference between the Exports (in Local Currency Unit) of Malawi and Exports (in Local Currency Unit) of Zambia?
Your response must be concise. 1.26e+11. In the year 2008, what is the difference between the Exports (in Local Currency Unit) in Brunei Darussalam and Exports (in Local Currency Unit) in Egypt, Arab Rep.?
Ensure brevity in your answer.  -2.80e+11. In the year 2008, what is the difference between the Exports (in Local Currency Unit) in Brunei Darussalam and Exports (in Local Currency Unit) in Malawi?
Your answer should be very brief. -1.53e+11. In the year 2008, what is the difference between the Exports (in Local Currency Unit) of Brunei Darussalam and Exports (in Local Currency Unit) of Zambia?
Offer a very short reply. -3.43e+09. In the year 2008, what is the difference between the Exports (in Local Currency Unit) of Egypt, Arab Rep. and Exports (in Local Currency Unit) of Malawi?
Keep it short and to the point. 1.26e+11. In the year 2008, what is the difference between the Exports (in Local Currency Unit) in Egypt, Arab Rep. and Exports (in Local Currency Unit) in Zambia?
Make the answer very short. 2.76e+11. In the year 2008, what is the difference between the Exports (in Local Currency Unit) of Malawi and Exports (in Local Currency Unit) of Zambia?
Ensure brevity in your answer.  1.50e+11. In the year 2009, what is the difference between the Exports (in Local Currency Unit) of Brunei Darussalam and Exports (in Local Currency Unit) of Egypt, Arab Rep.?
Ensure brevity in your answer.  -2.49e+11. In the year 2009, what is the difference between the Exports (in Local Currency Unit) in Brunei Darussalam and Exports (in Local Currency Unit) in Malawi?
Keep it short and to the point. -1.64e+11. In the year 2009, what is the difference between the Exports (in Local Currency Unit) in Brunei Darussalam and Exports (in Local Currency Unit) in Zambia?
Offer a terse response. -1.13e+1. In the year 2009, what is the difference between the Exports (in Local Currency Unit) of Egypt, Arab Rep. and Exports (in Local Currency Unit) of Malawi?
Your answer should be compact. 8.51e+1. In the year 2009, what is the difference between the Exports (in Local Currency Unit) of Egypt, Arab Rep. and Exports (in Local Currency Unit) of Zambia?
Provide a succinct answer. 2.37e+11. In the year 2009, what is the difference between the Exports (in Local Currency Unit) in Malawi and Exports (in Local Currency Unit) in Zambia?
Offer a terse response. 1.52e+11. In the year 2010, what is the difference between the Exports (in Local Currency Unit) in Brunei Darussalam and Exports (in Local Currency Unit) in Egypt, Arab Rep.?
Your answer should be very brief. -2.44e+11. In the year 2010, what is the difference between the Exports (in Local Currency Unit) in Brunei Darussalam and Exports (in Local Currency Unit) in Malawi?
Provide a succinct answer. -2.25e+11. In the year 2010, what is the difference between the Exports (in Local Currency Unit) of Brunei Darussalam and Exports (in Local Currency Unit) of Zambia?
Your answer should be very brief. -2.23e+1. In the year 2010, what is the difference between the Exports (in Local Currency Unit) in Egypt, Arab Rep. and Exports (in Local Currency Unit) in Malawi?
Your answer should be very brief. 1.89e+1. In the year 2010, what is the difference between the Exports (in Local Currency Unit) of Egypt, Arab Rep. and Exports (in Local Currency Unit) of Zambia?
Offer a very short reply. 2.22e+11. In the year 2010, what is the difference between the Exports (in Local Currency Unit) in Malawi and Exports (in Local Currency Unit) in Zambia?
Offer a terse response. 2.03e+11. What is the ratio of the Exports (in Local Currency Unit) of Brunei Darussalam in 2004 to that in 2005?
Your response must be concise. 0.82. What is the ratio of the Exports (in Local Currency Unit) of Egypt, Arab Rep. in 2004 to that in 2005?
Your answer should be compact. 0.84. What is the ratio of the Exports (in Local Currency Unit) in Malawi in 2004 to that in 2005?
Make the answer very short. 0.91. What is the ratio of the Exports (in Local Currency Unit) in Zambia in 2004 to that in 2005?
Keep it short and to the point. 0.88. What is the ratio of the Exports (in Local Currency Unit) of Brunei Darussalam in 2004 to that in 2006?
Your answer should be very brief. 0.7. What is the ratio of the Exports (in Local Currency Unit) of Egypt, Arab Rep. in 2004 to that in 2006?
Provide a short and direct response. 0.74. What is the ratio of the Exports (in Local Currency Unit) in Malawi in 2004 to that in 2006?
Your response must be concise. 0.74. What is the ratio of the Exports (in Local Currency Unit) of Zambia in 2004 to that in 2006?
Your response must be concise. 0.67. What is the ratio of the Exports (in Local Currency Unit) of Brunei Darussalam in 2004 to that in 2007?
Offer a terse response. 0.73. What is the ratio of the Exports (in Local Currency Unit) in Egypt, Arab Rep. in 2004 to that in 2007?
Make the answer very short. 0.61. What is the ratio of the Exports (in Local Currency Unit) of Malawi in 2004 to that in 2007?
Provide a succinct answer. 0.49. What is the ratio of the Exports (in Local Currency Unit) of Zambia in 2004 to that in 2007?
Your response must be concise. 0.53. What is the ratio of the Exports (in Local Currency Unit) in Brunei Darussalam in 2004 to that in 2008?
Offer a terse response. 0.57. What is the ratio of the Exports (in Local Currency Unit) of Egypt, Arab Rep. in 2004 to that in 2008?
Offer a terse response. 0.46. What is the ratio of the Exports (in Local Currency Unit) of Malawi in 2004 to that in 2008?
Provide a short and direct response. 0.42. What is the ratio of the Exports (in Local Currency Unit) in Zambia in 2004 to that in 2008?
Your answer should be compact. 0.51. What is the ratio of the Exports (in Local Currency Unit) of Brunei Darussalam in 2004 to that in 2009?
Your answer should be compact. 0.81. What is the ratio of the Exports (in Local Currency Unit) of Egypt, Arab Rep. in 2004 to that in 2009?
Keep it short and to the point. 0.53. What is the ratio of the Exports (in Local Currency Unit) of Malawi in 2004 to that in 2009?
Keep it short and to the point. 0.41. What is the ratio of the Exports (in Local Currency Unit) in Zambia in 2004 to that in 2009?
Your answer should be very brief. 0.44. What is the ratio of the Exports (in Local Currency Unit) in Brunei Darussalam in 2004 to that in 2010?
Provide a succinct answer. 0.67. What is the ratio of the Exports (in Local Currency Unit) of Egypt, Arab Rep. in 2004 to that in 2010?
Your response must be concise. 0.53. What is the ratio of the Exports (in Local Currency Unit) in Malawi in 2004 to that in 2010?
Your answer should be very brief. 0.3. What is the ratio of the Exports (in Local Currency Unit) in Zambia in 2004 to that in 2010?
Offer a very short reply. 0.28. What is the ratio of the Exports (in Local Currency Unit) in Brunei Darussalam in 2005 to that in 2006?
Make the answer very short. 0.85. What is the ratio of the Exports (in Local Currency Unit) in Egypt, Arab Rep. in 2005 to that in 2006?
Your answer should be compact. 0.88. What is the ratio of the Exports (in Local Currency Unit) of Malawi in 2005 to that in 2006?
Offer a very short reply. 0.82. What is the ratio of the Exports (in Local Currency Unit) of Zambia in 2005 to that in 2006?
Make the answer very short. 0.76. What is the ratio of the Exports (in Local Currency Unit) in Brunei Darussalam in 2005 to that in 2007?
Your answer should be compact. 0.89. What is the ratio of the Exports (in Local Currency Unit) of Egypt, Arab Rep. in 2005 to that in 2007?
Offer a terse response. 0.73. What is the ratio of the Exports (in Local Currency Unit) in Malawi in 2005 to that in 2007?
Provide a short and direct response. 0.54. What is the ratio of the Exports (in Local Currency Unit) of Zambia in 2005 to that in 2007?
Give a very brief answer. 0.6. What is the ratio of the Exports (in Local Currency Unit) in Brunei Darussalam in 2005 to that in 2008?
Provide a succinct answer. 0.7. What is the ratio of the Exports (in Local Currency Unit) in Egypt, Arab Rep. in 2005 to that in 2008?
Make the answer very short. 0.55. What is the ratio of the Exports (in Local Currency Unit) of Malawi in 2005 to that in 2008?
Offer a very short reply. 0.46. What is the ratio of the Exports (in Local Currency Unit) of Zambia in 2005 to that in 2008?
Your answer should be very brief. 0.59. What is the ratio of the Exports (in Local Currency Unit) of Brunei Darussalam in 2005 to that in 2009?
Provide a succinct answer. 0.98. What is the ratio of the Exports (in Local Currency Unit) of Egypt, Arab Rep. in 2005 to that in 2009?
Keep it short and to the point. 0.63. What is the ratio of the Exports (in Local Currency Unit) of Malawi in 2005 to that in 2009?
Ensure brevity in your answer.  0.45. What is the ratio of the Exports (in Local Currency Unit) in Zambia in 2005 to that in 2009?
Make the answer very short. 0.5. What is the ratio of the Exports (in Local Currency Unit) in Brunei Darussalam in 2005 to that in 2010?
Give a very brief answer. 0.81. What is the ratio of the Exports (in Local Currency Unit) in Egypt, Arab Rep. in 2005 to that in 2010?
Your answer should be compact. 0.63. What is the ratio of the Exports (in Local Currency Unit) in Malawi in 2005 to that in 2010?
Offer a very short reply. 0.33. What is the ratio of the Exports (in Local Currency Unit) in Zambia in 2005 to that in 2010?
Your response must be concise. 0.32. What is the ratio of the Exports (in Local Currency Unit) of Brunei Darussalam in 2006 to that in 2007?
Provide a succinct answer. 1.04. What is the ratio of the Exports (in Local Currency Unit) in Egypt, Arab Rep. in 2006 to that in 2007?
Offer a very short reply. 0.82. What is the ratio of the Exports (in Local Currency Unit) in Malawi in 2006 to that in 2007?
Your answer should be very brief. 0.66. What is the ratio of the Exports (in Local Currency Unit) of Zambia in 2006 to that in 2007?
Your answer should be compact. 0.79. What is the ratio of the Exports (in Local Currency Unit) in Brunei Darussalam in 2006 to that in 2008?
Give a very brief answer. 0.82. What is the ratio of the Exports (in Local Currency Unit) of Egypt, Arab Rep. in 2006 to that in 2008?
Ensure brevity in your answer.  0.63. What is the ratio of the Exports (in Local Currency Unit) of Malawi in 2006 to that in 2008?
Offer a terse response. 0.57. What is the ratio of the Exports (in Local Currency Unit) of Zambia in 2006 to that in 2008?
Your answer should be compact. 0.77. What is the ratio of the Exports (in Local Currency Unit) of Brunei Darussalam in 2006 to that in 2009?
Provide a short and direct response. 1.15. What is the ratio of the Exports (in Local Currency Unit) in Egypt, Arab Rep. in 2006 to that in 2009?
Offer a very short reply. 0.71. What is the ratio of the Exports (in Local Currency Unit) in Malawi in 2006 to that in 2009?
Your answer should be very brief. 0.55. What is the ratio of the Exports (in Local Currency Unit) of Zambia in 2006 to that in 2009?
Offer a terse response. 0.66. What is the ratio of the Exports (in Local Currency Unit) of Brunei Darussalam in 2006 to that in 2010?
Your answer should be compact. 0.95. What is the ratio of the Exports (in Local Currency Unit) in Egypt, Arab Rep. in 2006 to that in 2010?
Keep it short and to the point. 0.72. What is the ratio of the Exports (in Local Currency Unit) in Malawi in 2006 to that in 2010?
Provide a succinct answer. 0.4. What is the ratio of the Exports (in Local Currency Unit) of Zambia in 2006 to that in 2010?
Your answer should be very brief. 0.42. What is the ratio of the Exports (in Local Currency Unit) in Brunei Darussalam in 2007 to that in 2008?
Offer a terse response. 0.78. What is the ratio of the Exports (in Local Currency Unit) in Egypt, Arab Rep. in 2007 to that in 2008?
Give a very brief answer. 0.76. What is the ratio of the Exports (in Local Currency Unit) in Malawi in 2007 to that in 2008?
Give a very brief answer. 0.85. What is the ratio of the Exports (in Local Currency Unit) in Zambia in 2007 to that in 2008?
Give a very brief answer. 0.97. What is the ratio of the Exports (in Local Currency Unit) of Brunei Darussalam in 2007 to that in 2009?
Make the answer very short. 1.1. What is the ratio of the Exports (in Local Currency Unit) of Egypt, Arab Rep. in 2007 to that in 2009?
Your response must be concise. 0.87. What is the ratio of the Exports (in Local Currency Unit) in Malawi in 2007 to that in 2009?
Ensure brevity in your answer.  0.83. What is the ratio of the Exports (in Local Currency Unit) of Zambia in 2007 to that in 2009?
Ensure brevity in your answer.  0.84. What is the ratio of the Exports (in Local Currency Unit) in Brunei Darussalam in 2007 to that in 2010?
Give a very brief answer. 0.91. What is the ratio of the Exports (in Local Currency Unit) of Egypt, Arab Rep. in 2007 to that in 2010?
Keep it short and to the point. 0.87. What is the ratio of the Exports (in Local Currency Unit) in Malawi in 2007 to that in 2010?
Offer a very short reply. 0.61. What is the ratio of the Exports (in Local Currency Unit) of Zambia in 2007 to that in 2010?
Offer a very short reply. 0.53. What is the ratio of the Exports (in Local Currency Unit) in Brunei Darussalam in 2008 to that in 2009?
Make the answer very short. 1.41. What is the ratio of the Exports (in Local Currency Unit) of Egypt, Arab Rep. in 2008 to that in 2009?
Your answer should be compact. 1.14. What is the ratio of the Exports (in Local Currency Unit) of Malawi in 2008 to that in 2009?
Provide a short and direct response. 0.97. What is the ratio of the Exports (in Local Currency Unit) of Zambia in 2008 to that in 2009?
Make the answer very short. 0.86. What is the ratio of the Exports (in Local Currency Unit) in Brunei Darussalam in 2008 to that in 2010?
Your response must be concise. 1.16. What is the ratio of the Exports (in Local Currency Unit) in Egypt, Arab Rep. in 2008 to that in 2010?
Your answer should be very brief. 1.15. What is the ratio of the Exports (in Local Currency Unit) of Malawi in 2008 to that in 2010?
Make the answer very short. 0.71. What is the ratio of the Exports (in Local Currency Unit) in Zambia in 2008 to that in 2010?
Provide a short and direct response. 0.54. What is the ratio of the Exports (in Local Currency Unit) of Brunei Darussalam in 2009 to that in 2010?
Offer a terse response. 0.83. What is the ratio of the Exports (in Local Currency Unit) in Egypt, Arab Rep. in 2009 to that in 2010?
Offer a very short reply. 1.01. What is the ratio of the Exports (in Local Currency Unit) of Malawi in 2009 to that in 2010?
Keep it short and to the point. 0.73. What is the ratio of the Exports (in Local Currency Unit) of Zambia in 2009 to that in 2010?
Give a very brief answer. 0.63. What is the difference between the highest and the second highest Exports (in Local Currency Unit) of Brunei Darussalam?
Your response must be concise. 2.23e+09. What is the difference between the highest and the second highest Exports (in Local Currency Unit) in Egypt, Arab Rep.?
Offer a very short reply. 3.58e+1. What is the difference between the highest and the second highest Exports (in Local Currency Unit) of Malawi?
Give a very brief answer. 6.36e+1. What is the difference between the highest and the second highest Exports (in Local Currency Unit) of Zambia?
Offer a very short reply. 1.34e+1. What is the difference between the highest and the lowest Exports (in Local Currency Unit) in Brunei Darussalam?
Keep it short and to the point. 6.82e+09. What is the difference between the highest and the lowest Exports (in Local Currency Unit) in Egypt, Arab Rep.?
Your answer should be very brief. 1.59e+11. What is the difference between the highest and the lowest Exports (in Local Currency Unit) in Malawi?
Keep it short and to the point. 1.67e+11. What is the difference between the highest and the lowest Exports (in Local Currency Unit) of Zambia?
Offer a terse response. 2.60e+1. 